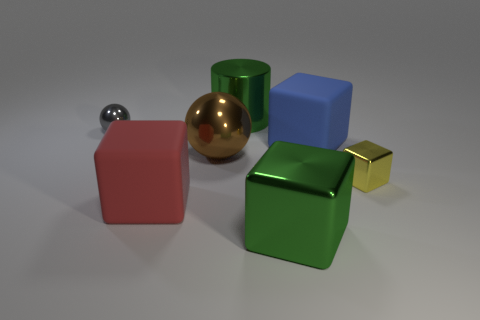There is a metallic object that is the same size as the yellow block; what shape is it?
Ensure brevity in your answer.  Sphere. What is the shape of the large thing behind the large object that is on the right side of the large metallic object in front of the red cube?
Your answer should be compact. Cylinder. Are there an equal number of small things right of the large red matte thing and yellow metal balls?
Ensure brevity in your answer.  No. Is the size of the green cube the same as the blue object?
Provide a short and direct response. Yes. What number of metal things are either large blocks or big objects?
Make the answer very short. 3. What is the material of the brown ball that is the same size as the green cylinder?
Offer a terse response. Metal. What number of other things are there of the same material as the yellow cube
Offer a terse response. 4. Is the number of brown things that are behind the big green metallic cylinder less than the number of gray rubber cylinders?
Your answer should be very brief. No. Is the yellow shiny object the same shape as the large red rubber object?
Provide a short and direct response. Yes. How big is the block that is to the left of the green object that is on the right side of the green thing behind the large blue cube?
Keep it short and to the point. Large. 